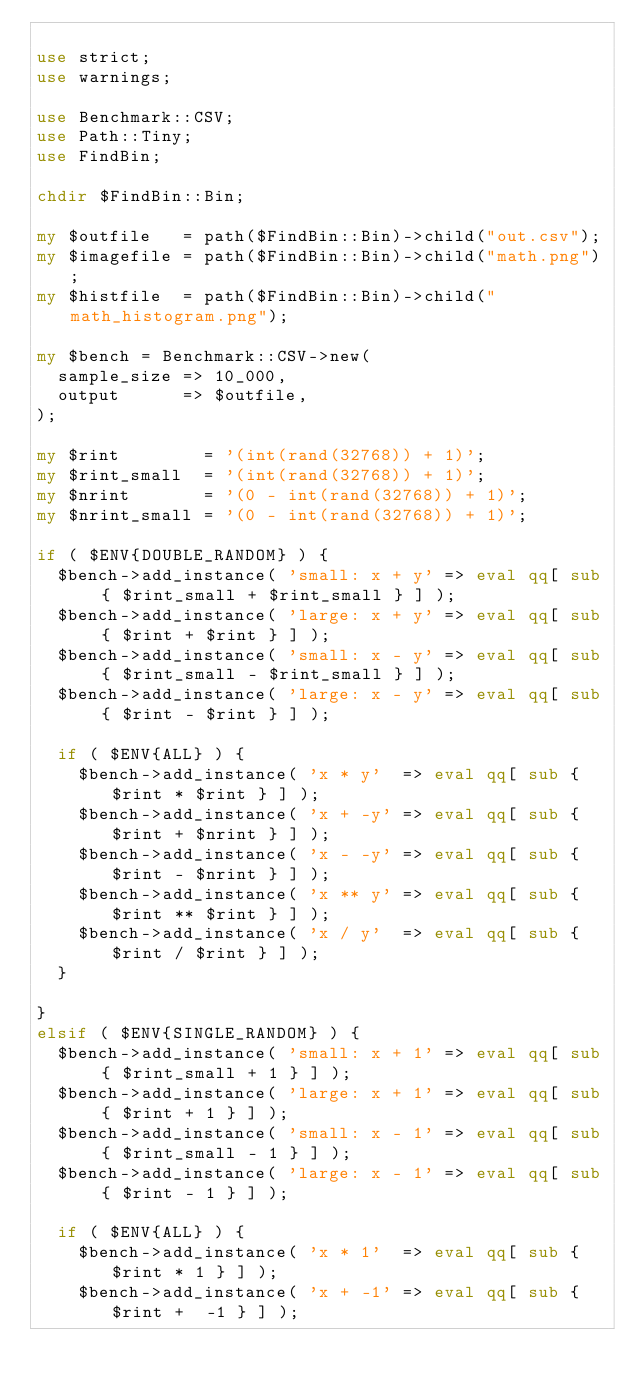Convert code to text. <code><loc_0><loc_0><loc_500><loc_500><_Perl_>
use strict;
use warnings;

use Benchmark::CSV;
use Path::Tiny;
use FindBin;

chdir $FindBin::Bin;

my $outfile   = path($FindBin::Bin)->child("out.csv");
my $imagefile = path($FindBin::Bin)->child("math.png");
my $histfile  = path($FindBin::Bin)->child("math_histogram.png");

my $bench = Benchmark::CSV->new(
  sample_size => 10_000,
  output      => $outfile,
);

my $rint        = '(int(rand(32768)) + 1)';
my $rint_small  = '(int(rand(32768)) + 1)';
my $nrint       = '(0 - int(rand(32768)) + 1)';
my $nrint_small = '(0 - int(rand(32768)) + 1)';

if ( $ENV{DOUBLE_RANDOM} ) {
  $bench->add_instance( 'small: x + y' => eval qq[ sub { $rint_small + $rint_small } ] );
  $bench->add_instance( 'large: x + y' => eval qq[ sub { $rint + $rint } ] );
  $bench->add_instance( 'small: x - y' => eval qq[ sub { $rint_small - $rint_small } ] );
  $bench->add_instance( 'large: x - y' => eval qq[ sub { $rint - $rint } ] );

  if ( $ENV{ALL} ) {
    $bench->add_instance( 'x * y'  => eval qq[ sub { $rint * $rint } ] );
    $bench->add_instance( 'x + -y' => eval qq[ sub { $rint + $nrint } ] );
    $bench->add_instance( 'x - -y' => eval qq[ sub { $rint - $nrint } ] );
    $bench->add_instance( 'x ** y' => eval qq[ sub { $rint ** $rint } ] );
    $bench->add_instance( 'x / y'  => eval qq[ sub { $rint / $rint } ] );
  }

}
elsif ( $ENV{SINGLE_RANDOM} ) {
  $bench->add_instance( 'small: x + 1' => eval qq[ sub { $rint_small + 1 } ] );
  $bench->add_instance( 'large: x + 1' => eval qq[ sub { $rint + 1 } ] );
  $bench->add_instance( 'small: x - 1' => eval qq[ sub { $rint_small - 1 } ] );
  $bench->add_instance( 'large: x - 1' => eval qq[ sub { $rint - 1 } ] );

  if ( $ENV{ALL} ) {
    $bench->add_instance( 'x * 1'  => eval qq[ sub { $rint * 1 } ] );
    $bench->add_instance( 'x + -1' => eval qq[ sub { $rint +  -1 } ] );</code> 